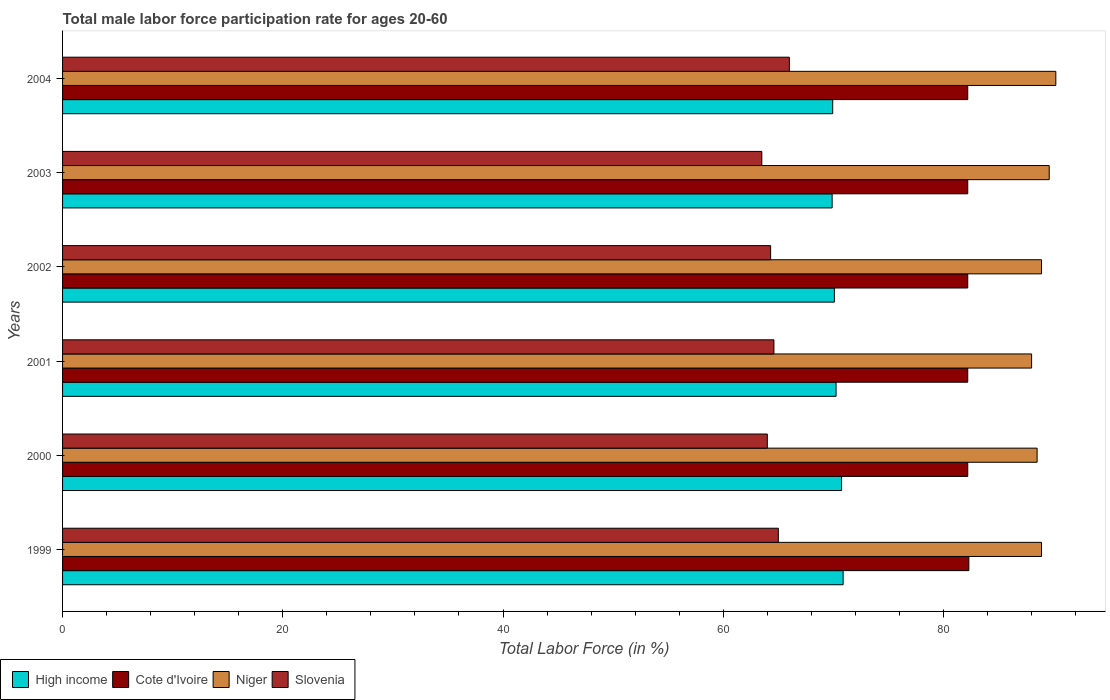How many different coloured bars are there?
Your answer should be compact. 4. Are the number of bars per tick equal to the number of legend labels?
Offer a very short reply. Yes. How many bars are there on the 2nd tick from the top?
Keep it short and to the point. 4. How many bars are there on the 3rd tick from the bottom?
Offer a very short reply. 4. What is the label of the 5th group of bars from the top?
Your answer should be compact. 2000. In how many cases, is the number of bars for a given year not equal to the number of legend labels?
Your answer should be very brief. 0. What is the male labor force participation rate in Cote d'Ivoire in 2001?
Give a very brief answer. 82.2. Across all years, what is the maximum male labor force participation rate in High income?
Your answer should be very brief. 70.88. Across all years, what is the minimum male labor force participation rate in High income?
Offer a terse response. 69.89. In which year was the male labor force participation rate in Cote d'Ivoire maximum?
Your answer should be compact. 1999. What is the total male labor force participation rate in Niger in the graph?
Ensure brevity in your answer.  534.1. What is the difference between the male labor force participation rate in High income in 2000 and that in 2003?
Keep it short and to the point. 0.86. What is the difference between the male labor force participation rate in Niger in 2004 and the male labor force participation rate in Slovenia in 2003?
Offer a terse response. 26.7. What is the average male labor force participation rate in Cote d'Ivoire per year?
Offer a terse response. 82.22. In the year 2004, what is the difference between the male labor force participation rate in Slovenia and male labor force participation rate in High income?
Your answer should be very brief. -3.94. In how many years, is the male labor force participation rate in Slovenia greater than 84 %?
Offer a very short reply. 0. What is the ratio of the male labor force participation rate in Niger in 2001 to that in 2004?
Keep it short and to the point. 0.98. Is the male labor force participation rate in Slovenia in 1999 less than that in 2002?
Give a very brief answer. No. What is the difference between the highest and the second highest male labor force participation rate in Cote d'Ivoire?
Ensure brevity in your answer.  0.1. What is the difference between the highest and the lowest male labor force participation rate in High income?
Make the answer very short. 1. In how many years, is the male labor force participation rate in High income greater than the average male labor force participation rate in High income taken over all years?
Your response must be concise. 2. What does the 1st bar from the top in 2000 represents?
Ensure brevity in your answer.  Slovenia. What does the 3rd bar from the bottom in 2000 represents?
Your response must be concise. Niger. Is it the case that in every year, the sum of the male labor force participation rate in Slovenia and male labor force participation rate in Niger is greater than the male labor force participation rate in Cote d'Ivoire?
Offer a very short reply. Yes. How many bars are there?
Make the answer very short. 24. Are all the bars in the graph horizontal?
Provide a short and direct response. Yes. Does the graph contain any zero values?
Ensure brevity in your answer.  No. How many legend labels are there?
Your response must be concise. 4. What is the title of the graph?
Provide a short and direct response. Total male labor force participation rate for ages 20-60. Does "Turkmenistan" appear as one of the legend labels in the graph?
Offer a terse response. No. What is the label or title of the X-axis?
Make the answer very short. Total Labor Force (in %). What is the Total Labor Force (in %) of High income in 1999?
Your answer should be very brief. 70.88. What is the Total Labor Force (in %) of Cote d'Ivoire in 1999?
Your response must be concise. 82.3. What is the Total Labor Force (in %) in Niger in 1999?
Provide a short and direct response. 88.9. What is the Total Labor Force (in %) of High income in 2000?
Your answer should be very brief. 70.75. What is the Total Labor Force (in %) in Cote d'Ivoire in 2000?
Your answer should be compact. 82.2. What is the Total Labor Force (in %) in Niger in 2000?
Give a very brief answer. 88.5. What is the Total Labor Force (in %) of High income in 2001?
Offer a terse response. 70.24. What is the Total Labor Force (in %) of Cote d'Ivoire in 2001?
Ensure brevity in your answer.  82.2. What is the Total Labor Force (in %) of Slovenia in 2001?
Provide a succinct answer. 64.6. What is the Total Labor Force (in %) of High income in 2002?
Your response must be concise. 70.09. What is the Total Labor Force (in %) of Cote d'Ivoire in 2002?
Provide a succinct answer. 82.2. What is the Total Labor Force (in %) of Niger in 2002?
Offer a terse response. 88.9. What is the Total Labor Force (in %) of Slovenia in 2002?
Your response must be concise. 64.3. What is the Total Labor Force (in %) of High income in 2003?
Offer a very short reply. 69.89. What is the Total Labor Force (in %) in Cote d'Ivoire in 2003?
Your answer should be very brief. 82.2. What is the Total Labor Force (in %) in Niger in 2003?
Give a very brief answer. 89.6. What is the Total Labor Force (in %) of Slovenia in 2003?
Give a very brief answer. 63.5. What is the Total Labor Force (in %) in High income in 2004?
Your answer should be compact. 69.94. What is the Total Labor Force (in %) of Cote d'Ivoire in 2004?
Make the answer very short. 82.2. What is the Total Labor Force (in %) of Niger in 2004?
Your answer should be very brief. 90.2. What is the Total Labor Force (in %) in Slovenia in 2004?
Your response must be concise. 66. Across all years, what is the maximum Total Labor Force (in %) of High income?
Keep it short and to the point. 70.88. Across all years, what is the maximum Total Labor Force (in %) in Cote d'Ivoire?
Offer a terse response. 82.3. Across all years, what is the maximum Total Labor Force (in %) in Niger?
Provide a succinct answer. 90.2. Across all years, what is the maximum Total Labor Force (in %) in Slovenia?
Your answer should be very brief. 66. Across all years, what is the minimum Total Labor Force (in %) in High income?
Provide a short and direct response. 69.89. Across all years, what is the minimum Total Labor Force (in %) in Cote d'Ivoire?
Provide a short and direct response. 82.2. Across all years, what is the minimum Total Labor Force (in %) of Slovenia?
Make the answer very short. 63.5. What is the total Total Labor Force (in %) in High income in the graph?
Offer a terse response. 421.79. What is the total Total Labor Force (in %) in Cote d'Ivoire in the graph?
Offer a very short reply. 493.3. What is the total Total Labor Force (in %) of Niger in the graph?
Ensure brevity in your answer.  534.1. What is the total Total Labor Force (in %) of Slovenia in the graph?
Keep it short and to the point. 387.4. What is the difference between the Total Labor Force (in %) in High income in 1999 and that in 2000?
Your answer should be very brief. 0.14. What is the difference between the Total Labor Force (in %) in Slovenia in 1999 and that in 2000?
Your answer should be very brief. 1. What is the difference between the Total Labor Force (in %) of High income in 1999 and that in 2001?
Your answer should be compact. 0.64. What is the difference between the Total Labor Force (in %) in Niger in 1999 and that in 2001?
Offer a very short reply. 0.9. What is the difference between the Total Labor Force (in %) in Slovenia in 1999 and that in 2001?
Provide a succinct answer. 0.4. What is the difference between the Total Labor Force (in %) of High income in 1999 and that in 2002?
Ensure brevity in your answer.  0.79. What is the difference between the Total Labor Force (in %) in Cote d'Ivoire in 1999 and that in 2002?
Your answer should be very brief. 0.1. What is the difference between the Total Labor Force (in %) in Niger in 1999 and that in 2002?
Provide a short and direct response. 0. What is the difference between the Total Labor Force (in %) in Slovenia in 1999 and that in 2002?
Offer a terse response. 0.7. What is the difference between the Total Labor Force (in %) of High income in 1999 and that in 2003?
Offer a terse response. 1. What is the difference between the Total Labor Force (in %) in High income in 1999 and that in 2004?
Give a very brief answer. 0.95. What is the difference between the Total Labor Force (in %) in Niger in 1999 and that in 2004?
Your answer should be very brief. -1.3. What is the difference between the Total Labor Force (in %) of High income in 2000 and that in 2001?
Give a very brief answer. 0.5. What is the difference between the Total Labor Force (in %) of High income in 2000 and that in 2002?
Provide a short and direct response. 0.66. What is the difference between the Total Labor Force (in %) in Cote d'Ivoire in 2000 and that in 2002?
Your answer should be compact. 0. What is the difference between the Total Labor Force (in %) in Niger in 2000 and that in 2002?
Your answer should be compact. -0.4. What is the difference between the Total Labor Force (in %) of Slovenia in 2000 and that in 2002?
Your answer should be very brief. -0.3. What is the difference between the Total Labor Force (in %) of High income in 2000 and that in 2003?
Keep it short and to the point. 0.86. What is the difference between the Total Labor Force (in %) in Cote d'Ivoire in 2000 and that in 2003?
Offer a terse response. 0. What is the difference between the Total Labor Force (in %) of Niger in 2000 and that in 2003?
Offer a very short reply. -1.1. What is the difference between the Total Labor Force (in %) of High income in 2000 and that in 2004?
Your response must be concise. 0.81. What is the difference between the Total Labor Force (in %) in Niger in 2000 and that in 2004?
Ensure brevity in your answer.  -1.7. What is the difference between the Total Labor Force (in %) of Slovenia in 2000 and that in 2004?
Your answer should be very brief. -2. What is the difference between the Total Labor Force (in %) of High income in 2001 and that in 2002?
Give a very brief answer. 0.15. What is the difference between the Total Labor Force (in %) in Niger in 2001 and that in 2002?
Make the answer very short. -0.9. What is the difference between the Total Labor Force (in %) of High income in 2001 and that in 2003?
Provide a short and direct response. 0.36. What is the difference between the Total Labor Force (in %) in Cote d'Ivoire in 2001 and that in 2003?
Your answer should be compact. 0. What is the difference between the Total Labor Force (in %) in Niger in 2001 and that in 2003?
Offer a very short reply. -1.6. What is the difference between the Total Labor Force (in %) of Slovenia in 2001 and that in 2003?
Offer a very short reply. 1.1. What is the difference between the Total Labor Force (in %) in High income in 2001 and that in 2004?
Provide a short and direct response. 0.31. What is the difference between the Total Labor Force (in %) of Cote d'Ivoire in 2001 and that in 2004?
Ensure brevity in your answer.  0. What is the difference between the Total Labor Force (in %) of Slovenia in 2001 and that in 2004?
Provide a succinct answer. -1.4. What is the difference between the Total Labor Force (in %) in High income in 2002 and that in 2003?
Make the answer very short. 0.2. What is the difference between the Total Labor Force (in %) of Cote d'Ivoire in 2002 and that in 2003?
Give a very brief answer. 0. What is the difference between the Total Labor Force (in %) of High income in 2002 and that in 2004?
Your response must be concise. 0.15. What is the difference between the Total Labor Force (in %) in Cote d'Ivoire in 2002 and that in 2004?
Offer a terse response. 0. What is the difference between the Total Labor Force (in %) in Slovenia in 2002 and that in 2004?
Give a very brief answer. -1.7. What is the difference between the Total Labor Force (in %) of High income in 2003 and that in 2004?
Provide a short and direct response. -0.05. What is the difference between the Total Labor Force (in %) of Niger in 2003 and that in 2004?
Keep it short and to the point. -0.6. What is the difference between the Total Labor Force (in %) of High income in 1999 and the Total Labor Force (in %) of Cote d'Ivoire in 2000?
Give a very brief answer. -11.32. What is the difference between the Total Labor Force (in %) of High income in 1999 and the Total Labor Force (in %) of Niger in 2000?
Ensure brevity in your answer.  -17.62. What is the difference between the Total Labor Force (in %) of High income in 1999 and the Total Labor Force (in %) of Slovenia in 2000?
Your answer should be very brief. 6.88. What is the difference between the Total Labor Force (in %) of Niger in 1999 and the Total Labor Force (in %) of Slovenia in 2000?
Ensure brevity in your answer.  24.9. What is the difference between the Total Labor Force (in %) in High income in 1999 and the Total Labor Force (in %) in Cote d'Ivoire in 2001?
Provide a short and direct response. -11.32. What is the difference between the Total Labor Force (in %) of High income in 1999 and the Total Labor Force (in %) of Niger in 2001?
Your answer should be compact. -17.12. What is the difference between the Total Labor Force (in %) of High income in 1999 and the Total Labor Force (in %) of Slovenia in 2001?
Make the answer very short. 6.28. What is the difference between the Total Labor Force (in %) of Cote d'Ivoire in 1999 and the Total Labor Force (in %) of Niger in 2001?
Provide a succinct answer. -5.7. What is the difference between the Total Labor Force (in %) of Niger in 1999 and the Total Labor Force (in %) of Slovenia in 2001?
Your response must be concise. 24.3. What is the difference between the Total Labor Force (in %) in High income in 1999 and the Total Labor Force (in %) in Cote d'Ivoire in 2002?
Make the answer very short. -11.32. What is the difference between the Total Labor Force (in %) of High income in 1999 and the Total Labor Force (in %) of Niger in 2002?
Keep it short and to the point. -18.02. What is the difference between the Total Labor Force (in %) in High income in 1999 and the Total Labor Force (in %) in Slovenia in 2002?
Your response must be concise. 6.58. What is the difference between the Total Labor Force (in %) in Cote d'Ivoire in 1999 and the Total Labor Force (in %) in Niger in 2002?
Your response must be concise. -6.6. What is the difference between the Total Labor Force (in %) of Cote d'Ivoire in 1999 and the Total Labor Force (in %) of Slovenia in 2002?
Your answer should be very brief. 18. What is the difference between the Total Labor Force (in %) in Niger in 1999 and the Total Labor Force (in %) in Slovenia in 2002?
Offer a very short reply. 24.6. What is the difference between the Total Labor Force (in %) of High income in 1999 and the Total Labor Force (in %) of Cote d'Ivoire in 2003?
Your answer should be very brief. -11.32. What is the difference between the Total Labor Force (in %) of High income in 1999 and the Total Labor Force (in %) of Niger in 2003?
Offer a very short reply. -18.72. What is the difference between the Total Labor Force (in %) in High income in 1999 and the Total Labor Force (in %) in Slovenia in 2003?
Give a very brief answer. 7.38. What is the difference between the Total Labor Force (in %) in Cote d'Ivoire in 1999 and the Total Labor Force (in %) in Niger in 2003?
Your answer should be compact. -7.3. What is the difference between the Total Labor Force (in %) in Cote d'Ivoire in 1999 and the Total Labor Force (in %) in Slovenia in 2003?
Provide a succinct answer. 18.8. What is the difference between the Total Labor Force (in %) in Niger in 1999 and the Total Labor Force (in %) in Slovenia in 2003?
Provide a short and direct response. 25.4. What is the difference between the Total Labor Force (in %) of High income in 1999 and the Total Labor Force (in %) of Cote d'Ivoire in 2004?
Provide a succinct answer. -11.32. What is the difference between the Total Labor Force (in %) in High income in 1999 and the Total Labor Force (in %) in Niger in 2004?
Provide a short and direct response. -19.32. What is the difference between the Total Labor Force (in %) in High income in 1999 and the Total Labor Force (in %) in Slovenia in 2004?
Provide a short and direct response. 4.88. What is the difference between the Total Labor Force (in %) in Cote d'Ivoire in 1999 and the Total Labor Force (in %) in Niger in 2004?
Give a very brief answer. -7.9. What is the difference between the Total Labor Force (in %) in Cote d'Ivoire in 1999 and the Total Labor Force (in %) in Slovenia in 2004?
Ensure brevity in your answer.  16.3. What is the difference between the Total Labor Force (in %) in Niger in 1999 and the Total Labor Force (in %) in Slovenia in 2004?
Ensure brevity in your answer.  22.9. What is the difference between the Total Labor Force (in %) of High income in 2000 and the Total Labor Force (in %) of Cote d'Ivoire in 2001?
Keep it short and to the point. -11.45. What is the difference between the Total Labor Force (in %) in High income in 2000 and the Total Labor Force (in %) in Niger in 2001?
Ensure brevity in your answer.  -17.25. What is the difference between the Total Labor Force (in %) in High income in 2000 and the Total Labor Force (in %) in Slovenia in 2001?
Provide a succinct answer. 6.15. What is the difference between the Total Labor Force (in %) in Cote d'Ivoire in 2000 and the Total Labor Force (in %) in Niger in 2001?
Ensure brevity in your answer.  -5.8. What is the difference between the Total Labor Force (in %) of Niger in 2000 and the Total Labor Force (in %) of Slovenia in 2001?
Offer a very short reply. 23.9. What is the difference between the Total Labor Force (in %) in High income in 2000 and the Total Labor Force (in %) in Cote d'Ivoire in 2002?
Ensure brevity in your answer.  -11.45. What is the difference between the Total Labor Force (in %) of High income in 2000 and the Total Labor Force (in %) of Niger in 2002?
Make the answer very short. -18.15. What is the difference between the Total Labor Force (in %) in High income in 2000 and the Total Labor Force (in %) in Slovenia in 2002?
Give a very brief answer. 6.45. What is the difference between the Total Labor Force (in %) in Niger in 2000 and the Total Labor Force (in %) in Slovenia in 2002?
Offer a very short reply. 24.2. What is the difference between the Total Labor Force (in %) of High income in 2000 and the Total Labor Force (in %) of Cote d'Ivoire in 2003?
Give a very brief answer. -11.45. What is the difference between the Total Labor Force (in %) of High income in 2000 and the Total Labor Force (in %) of Niger in 2003?
Provide a short and direct response. -18.85. What is the difference between the Total Labor Force (in %) in High income in 2000 and the Total Labor Force (in %) in Slovenia in 2003?
Your answer should be compact. 7.25. What is the difference between the Total Labor Force (in %) in Cote d'Ivoire in 2000 and the Total Labor Force (in %) in Niger in 2003?
Offer a terse response. -7.4. What is the difference between the Total Labor Force (in %) of Cote d'Ivoire in 2000 and the Total Labor Force (in %) of Slovenia in 2003?
Ensure brevity in your answer.  18.7. What is the difference between the Total Labor Force (in %) in Niger in 2000 and the Total Labor Force (in %) in Slovenia in 2003?
Offer a terse response. 25. What is the difference between the Total Labor Force (in %) of High income in 2000 and the Total Labor Force (in %) of Cote d'Ivoire in 2004?
Keep it short and to the point. -11.45. What is the difference between the Total Labor Force (in %) of High income in 2000 and the Total Labor Force (in %) of Niger in 2004?
Offer a very short reply. -19.45. What is the difference between the Total Labor Force (in %) in High income in 2000 and the Total Labor Force (in %) in Slovenia in 2004?
Your response must be concise. 4.75. What is the difference between the Total Labor Force (in %) in Cote d'Ivoire in 2000 and the Total Labor Force (in %) in Niger in 2004?
Your answer should be compact. -8. What is the difference between the Total Labor Force (in %) of Niger in 2000 and the Total Labor Force (in %) of Slovenia in 2004?
Make the answer very short. 22.5. What is the difference between the Total Labor Force (in %) in High income in 2001 and the Total Labor Force (in %) in Cote d'Ivoire in 2002?
Offer a terse response. -11.96. What is the difference between the Total Labor Force (in %) of High income in 2001 and the Total Labor Force (in %) of Niger in 2002?
Ensure brevity in your answer.  -18.66. What is the difference between the Total Labor Force (in %) of High income in 2001 and the Total Labor Force (in %) of Slovenia in 2002?
Ensure brevity in your answer.  5.94. What is the difference between the Total Labor Force (in %) of Cote d'Ivoire in 2001 and the Total Labor Force (in %) of Niger in 2002?
Make the answer very short. -6.7. What is the difference between the Total Labor Force (in %) of Niger in 2001 and the Total Labor Force (in %) of Slovenia in 2002?
Offer a very short reply. 23.7. What is the difference between the Total Labor Force (in %) of High income in 2001 and the Total Labor Force (in %) of Cote d'Ivoire in 2003?
Your response must be concise. -11.96. What is the difference between the Total Labor Force (in %) in High income in 2001 and the Total Labor Force (in %) in Niger in 2003?
Ensure brevity in your answer.  -19.36. What is the difference between the Total Labor Force (in %) of High income in 2001 and the Total Labor Force (in %) of Slovenia in 2003?
Your answer should be very brief. 6.74. What is the difference between the Total Labor Force (in %) in High income in 2001 and the Total Labor Force (in %) in Cote d'Ivoire in 2004?
Your answer should be compact. -11.96. What is the difference between the Total Labor Force (in %) in High income in 2001 and the Total Labor Force (in %) in Niger in 2004?
Make the answer very short. -19.96. What is the difference between the Total Labor Force (in %) of High income in 2001 and the Total Labor Force (in %) of Slovenia in 2004?
Keep it short and to the point. 4.24. What is the difference between the Total Labor Force (in %) in Cote d'Ivoire in 2001 and the Total Labor Force (in %) in Niger in 2004?
Keep it short and to the point. -8. What is the difference between the Total Labor Force (in %) of Cote d'Ivoire in 2001 and the Total Labor Force (in %) of Slovenia in 2004?
Make the answer very short. 16.2. What is the difference between the Total Labor Force (in %) of Niger in 2001 and the Total Labor Force (in %) of Slovenia in 2004?
Ensure brevity in your answer.  22. What is the difference between the Total Labor Force (in %) of High income in 2002 and the Total Labor Force (in %) of Cote d'Ivoire in 2003?
Make the answer very short. -12.11. What is the difference between the Total Labor Force (in %) in High income in 2002 and the Total Labor Force (in %) in Niger in 2003?
Your answer should be compact. -19.51. What is the difference between the Total Labor Force (in %) of High income in 2002 and the Total Labor Force (in %) of Slovenia in 2003?
Your answer should be very brief. 6.59. What is the difference between the Total Labor Force (in %) in Cote d'Ivoire in 2002 and the Total Labor Force (in %) in Niger in 2003?
Your response must be concise. -7.4. What is the difference between the Total Labor Force (in %) in Niger in 2002 and the Total Labor Force (in %) in Slovenia in 2003?
Your response must be concise. 25.4. What is the difference between the Total Labor Force (in %) of High income in 2002 and the Total Labor Force (in %) of Cote d'Ivoire in 2004?
Ensure brevity in your answer.  -12.11. What is the difference between the Total Labor Force (in %) of High income in 2002 and the Total Labor Force (in %) of Niger in 2004?
Your answer should be very brief. -20.11. What is the difference between the Total Labor Force (in %) in High income in 2002 and the Total Labor Force (in %) in Slovenia in 2004?
Your response must be concise. 4.09. What is the difference between the Total Labor Force (in %) of Cote d'Ivoire in 2002 and the Total Labor Force (in %) of Niger in 2004?
Offer a terse response. -8. What is the difference between the Total Labor Force (in %) of Cote d'Ivoire in 2002 and the Total Labor Force (in %) of Slovenia in 2004?
Your answer should be compact. 16.2. What is the difference between the Total Labor Force (in %) of Niger in 2002 and the Total Labor Force (in %) of Slovenia in 2004?
Give a very brief answer. 22.9. What is the difference between the Total Labor Force (in %) of High income in 2003 and the Total Labor Force (in %) of Cote d'Ivoire in 2004?
Offer a terse response. -12.31. What is the difference between the Total Labor Force (in %) of High income in 2003 and the Total Labor Force (in %) of Niger in 2004?
Keep it short and to the point. -20.31. What is the difference between the Total Labor Force (in %) in High income in 2003 and the Total Labor Force (in %) in Slovenia in 2004?
Provide a succinct answer. 3.89. What is the difference between the Total Labor Force (in %) of Cote d'Ivoire in 2003 and the Total Labor Force (in %) of Niger in 2004?
Keep it short and to the point. -8. What is the difference between the Total Labor Force (in %) in Cote d'Ivoire in 2003 and the Total Labor Force (in %) in Slovenia in 2004?
Offer a terse response. 16.2. What is the difference between the Total Labor Force (in %) in Niger in 2003 and the Total Labor Force (in %) in Slovenia in 2004?
Offer a very short reply. 23.6. What is the average Total Labor Force (in %) in High income per year?
Provide a succinct answer. 70.3. What is the average Total Labor Force (in %) of Cote d'Ivoire per year?
Give a very brief answer. 82.22. What is the average Total Labor Force (in %) of Niger per year?
Make the answer very short. 89.02. What is the average Total Labor Force (in %) of Slovenia per year?
Provide a succinct answer. 64.57. In the year 1999, what is the difference between the Total Labor Force (in %) of High income and Total Labor Force (in %) of Cote d'Ivoire?
Provide a succinct answer. -11.42. In the year 1999, what is the difference between the Total Labor Force (in %) of High income and Total Labor Force (in %) of Niger?
Offer a terse response. -18.02. In the year 1999, what is the difference between the Total Labor Force (in %) of High income and Total Labor Force (in %) of Slovenia?
Your answer should be very brief. 5.88. In the year 1999, what is the difference between the Total Labor Force (in %) of Cote d'Ivoire and Total Labor Force (in %) of Niger?
Provide a short and direct response. -6.6. In the year 1999, what is the difference between the Total Labor Force (in %) of Niger and Total Labor Force (in %) of Slovenia?
Provide a short and direct response. 23.9. In the year 2000, what is the difference between the Total Labor Force (in %) of High income and Total Labor Force (in %) of Cote d'Ivoire?
Make the answer very short. -11.45. In the year 2000, what is the difference between the Total Labor Force (in %) of High income and Total Labor Force (in %) of Niger?
Offer a very short reply. -17.75. In the year 2000, what is the difference between the Total Labor Force (in %) in High income and Total Labor Force (in %) in Slovenia?
Offer a very short reply. 6.75. In the year 2000, what is the difference between the Total Labor Force (in %) of Cote d'Ivoire and Total Labor Force (in %) of Niger?
Your answer should be very brief. -6.3. In the year 2000, what is the difference between the Total Labor Force (in %) of Cote d'Ivoire and Total Labor Force (in %) of Slovenia?
Give a very brief answer. 18.2. In the year 2001, what is the difference between the Total Labor Force (in %) in High income and Total Labor Force (in %) in Cote d'Ivoire?
Your answer should be compact. -11.96. In the year 2001, what is the difference between the Total Labor Force (in %) in High income and Total Labor Force (in %) in Niger?
Your answer should be compact. -17.76. In the year 2001, what is the difference between the Total Labor Force (in %) in High income and Total Labor Force (in %) in Slovenia?
Provide a succinct answer. 5.64. In the year 2001, what is the difference between the Total Labor Force (in %) of Cote d'Ivoire and Total Labor Force (in %) of Slovenia?
Offer a very short reply. 17.6. In the year 2001, what is the difference between the Total Labor Force (in %) in Niger and Total Labor Force (in %) in Slovenia?
Provide a succinct answer. 23.4. In the year 2002, what is the difference between the Total Labor Force (in %) of High income and Total Labor Force (in %) of Cote d'Ivoire?
Give a very brief answer. -12.11. In the year 2002, what is the difference between the Total Labor Force (in %) in High income and Total Labor Force (in %) in Niger?
Your answer should be very brief. -18.81. In the year 2002, what is the difference between the Total Labor Force (in %) of High income and Total Labor Force (in %) of Slovenia?
Your response must be concise. 5.79. In the year 2002, what is the difference between the Total Labor Force (in %) in Cote d'Ivoire and Total Labor Force (in %) in Slovenia?
Offer a terse response. 17.9. In the year 2002, what is the difference between the Total Labor Force (in %) in Niger and Total Labor Force (in %) in Slovenia?
Provide a short and direct response. 24.6. In the year 2003, what is the difference between the Total Labor Force (in %) in High income and Total Labor Force (in %) in Cote d'Ivoire?
Provide a short and direct response. -12.31. In the year 2003, what is the difference between the Total Labor Force (in %) in High income and Total Labor Force (in %) in Niger?
Offer a terse response. -19.71. In the year 2003, what is the difference between the Total Labor Force (in %) of High income and Total Labor Force (in %) of Slovenia?
Offer a terse response. 6.39. In the year 2003, what is the difference between the Total Labor Force (in %) in Cote d'Ivoire and Total Labor Force (in %) in Slovenia?
Keep it short and to the point. 18.7. In the year 2003, what is the difference between the Total Labor Force (in %) of Niger and Total Labor Force (in %) of Slovenia?
Provide a succinct answer. 26.1. In the year 2004, what is the difference between the Total Labor Force (in %) in High income and Total Labor Force (in %) in Cote d'Ivoire?
Offer a terse response. -12.26. In the year 2004, what is the difference between the Total Labor Force (in %) of High income and Total Labor Force (in %) of Niger?
Give a very brief answer. -20.26. In the year 2004, what is the difference between the Total Labor Force (in %) in High income and Total Labor Force (in %) in Slovenia?
Your response must be concise. 3.94. In the year 2004, what is the difference between the Total Labor Force (in %) in Cote d'Ivoire and Total Labor Force (in %) in Niger?
Give a very brief answer. -8. In the year 2004, what is the difference between the Total Labor Force (in %) of Niger and Total Labor Force (in %) of Slovenia?
Your answer should be very brief. 24.2. What is the ratio of the Total Labor Force (in %) of Cote d'Ivoire in 1999 to that in 2000?
Your response must be concise. 1. What is the ratio of the Total Labor Force (in %) of Niger in 1999 to that in 2000?
Make the answer very short. 1. What is the ratio of the Total Labor Force (in %) of Slovenia in 1999 to that in 2000?
Make the answer very short. 1.02. What is the ratio of the Total Labor Force (in %) of High income in 1999 to that in 2001?
Give a very brief answer. 1.01. What is the ratio of the Total Labor Force (in %) in Cote d'Ivoire in 1999 to that in 2001?
Keep it short and to the point. 1. What is the ratio of the Total Labor Force (in %) of Niger in 1999 to that in 2001?
Ensure brevity in your answer.  1.01. What is the ratio of the Total Labor Force (in %) in Slovenia in 1999 to that in 2001?
Provide a succinct answer. 1.01. What is the ratio of the Total Labor Force (in %) of High income in 1999 to that in 2002?
Give a very brief answer. 1.01. What is the ratio of the Total Labor Force (in %) in Niger in 1999 to that in 2002?
Make the answer very short. 1. What is the ratio of the Total Labor Force (in %) in Slovenia in 1999 to that in 2002?
Your answer should be compact. 1.01. What is the ratio of the Total Labor Force (in %) in High income in 1999 to that in 2003?
Keep it short and to the point. 1.01. What is the ratio of the Total Labor Force (in %) in Cote d'Ivoire in 1999 to that in 2003?
Ensure brevity in your answer.  1. What is the ratio of the Total Labor Force (in %) in Niger in 1999 to that in 2003?
Provide a succinct answer. 0.99. What is the ratio of the Total Labor Force (in %) of Slovenia in 1999 to that in 2003?
Your response must be concise. 1.02. What is the ratio of the Total Labor Force (in %) of High income in 1999 to that in 2004?
Give a very brief answer. 1.01. What is the ratio of the Total Labor Force (in %) in Cote d'Ivoire in 1999 to that in 2004?
Your response must be concise. 1. What is the ratio of the Total Labor Force (in %) in Niger in 1999 to that in 2004?
Your answer should be very brief. 0.99. What is the ratio of the Total Labor Force (in %) of Slovenia in 1999 to that in 2004?
Your response must be concise. 0.98. What is the ratio of the Total Labor Force (in %) of High income in 2000 to that in 2001?
Offer a terse response. 1.01. What is the ratio of the Total Labor Force (in %) of Niger in 2000 to that in 2001?
Your response must be concise. 1.01. What is the ratio of the Total Labor Force (in %) in Slovenia in 2000 to that in 2001?
Ensure brevity in your answer.  0.99. What is the ratio of the Total Labor Force (in %) of High income in 2000 to that in 2002?
Your answer should be compact. 1.01. What is the ratio of the Total Labor Force (in %) of High income in 2000 to that in 2003?
Keep it short and to the point. 1.01. What is the ratio of the Total Labor Force (in %) in Cote d'Ivoire in 2000 to that in 2003?
Offer a very short reply. 1. What is the ratio of the Total Labor Force (in %) of Niger in 2000 to that in 2003?
Offer a terse response. 0.99. What is the ratio of the Total Labor Force (in %) in Slovenia in 2000 to that in 2003?
Provide a succinct answer. 1.01. What is the ratio of the Total Labor Force (in %) of High income in 2000 to that in 2004?
Give a very brief answer. 1.01. What is the ratio of the Total Labor Force (in %) in Cote d'Ivoire in 2000 to that in 2004?
Offer a terse response. 1. What is the ratio of the Total Labor Force (in %) in Niger in 2000 to that in 2004?
Provide a short and direct response. 0.98. What is the ratio of the Total Labor Force (in %) in Slovenia in 2000 to that in 2004?
Offer a terse response. 0.97. What is the ratio of the Total Labor Force (in %) of High income in 2001 to that in 2002?
Offer a very short reply. 1. What is the ratio of the Total Labor Force (in %) in Cote d'Ivoire in 2001 to that in 2002?
Provide a short and direct response. 1. What is the ratio of the Total Labor Force (in %) in Slovenia in 2001 to that in 2002?
Your response must be concise. 1. What is the ratio of the Total Labor Force (in %) of High income in 2001 to that in 2003?
Make the answer very short. 1.01. What is the ratio of the Total Labor Force (in %) in Niger in 2001 to that in 2003?
Make the answer very short. 0.98. What is the ratio of the Total Labor Force (in %) in Slovenia in 2001 to that in 2003?
Your answer should be compact. 1.02. What is the ratio of the Total Labor Force (in %) in High income in 2001 to that in 2004?
Provide a short and direct response. 1. What is the ratio of the Total Labor Force (in %) in Cote d'Ivoire in 2001 to that in 2004?
Provide a succinct answer. 1. What is the ratio of the Total Labor Force (in %) of Niger in 2001 to that in 2004?
Offer a terse response. 0.98. What is the ratio of the Total Labor Force (in %) in Slovenia in 2001 to that in 2004?
Your answer should be compact. 0.98. What is the ratio of the Total Labor Force (in %) in High income in 2002 to that in 2003?
Keep it short and to the point. 1. What is the ratio of the Total Labor Force (in %) in Cote d'Ivoire in 2002 to that in 2003?
Keep it short and to the point. 1. What is the ratio of the Total Labor Force (in %) of Slovenia in 2002 to that in 2003?
Keep it short and to the point. 1.01. What is the ratio of the Total Labor Force (in %) in Cote d'Ivoire in 2002 to that in 2004?
Provide a succinct answer. 1. What is the ratio of the Total Labor Force (in %) of Niger in 2002 to that in 2004?
Make the answer very short. 0.99. What is the ratio of the Total Labor Force (in %) of Slovenia in 2002 to that in 2004?
Keep it short and to the point. 0.97. What is the ratio of the Total Labor Force (in %) of Cote d'Ivoire in 2003 to that in 2004?
Make the answer very short. 1. What is the ratio of the Total Labor Force (in %) in Niger in 2003 to that in 2004?
Keep it short and to the point. 0.99. What is the ratio of the Total Labor Force (in %) in Slovenia in 2003 to that in 2004?
Offer a very short reply. 0.96. What is the difference between the highest and the second highest Total Labor Force (in %) in High income?
Your response must be concise. 0.14. What is the difference between the highest and the second highest Total Labor Force (in %) of Cote d'Ivoire?
Your answer should be very brief. 0.1. What is the difference between the highest and the second highest Total Labor Force (in %) of Niger?
Offer a very short reply. 0.6. What is the difference between the highest and the lowest Total Labor Force (in %) in High income?
Make the answer very short. 1. What is the difference between the highest and the lowest Total Labor Force (in %) of Cote d'Ivoire?
Ensure brevity in your answer.  0.1. What is the difference between the highest and the lowest Total Labor Force (in %) of Niger?
Keep it short and to the point. 2.2. 